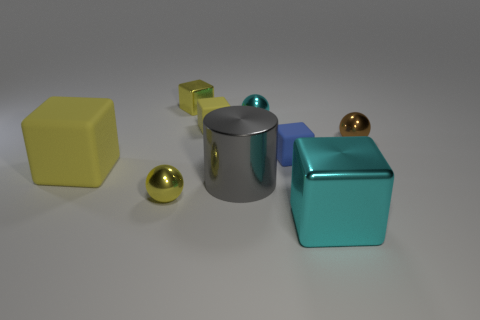Add 1 gray shiny objects. How many objects exist? 10 Subtract all cubes. How many objects are left? 4 Subtract all blue blocks. How many blocks are left? 4 Subtract all matte cubes. How many cubes are left? 2 Subtract 0 green cubes. How many objects are left? 9 Subtract 2 blocks. How many blocks are left? 3 Subtract all yellow cylinders. Subtract all green blocks. How many cylinders are left? 1 Subtract all brown cylinders. How many blue spheres are left? 0 Subtract all tiny yellow rubber cubes. Subtract all metal things. How many objects are left? 2 Add 4 blue matte cubes. How many blue matte cubes are left? 5 